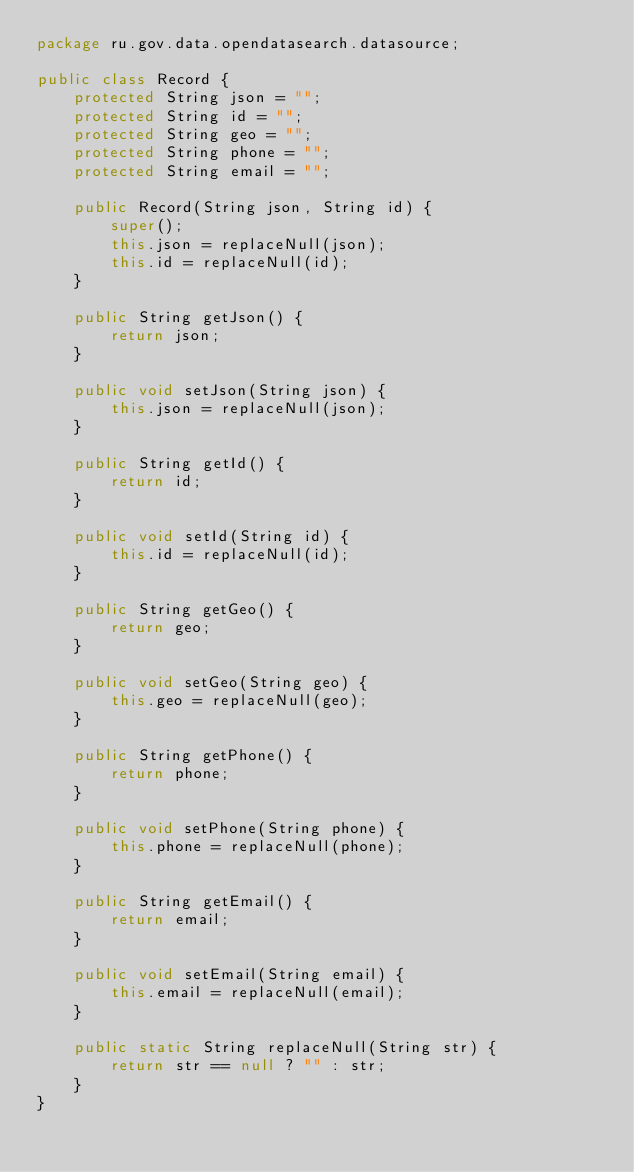Convert code to text. <code><loc_0><loc_0><loc_500><loc_500><_Java_>package ru.gov.data.opendatasearch.datasource;

public class Record {
    protected String json = "";
    protected String id = "";
    protected String geo = "";
    protected String phone = "";
    protected String email = "";

    public Record(String json, String id) {
        super();
        this.json = replaceNull(json);
        this.id = replaceNull(id);
    }

    public String getJson() {
        return json;
    }

    public void setJson(String json) {
        this.json = replaceNull(json);
    }

    public String getId() {
        return id;
    }

    public void setId(String id) {
        this.id = replaceNull(id);
    }

    public String getGeo() {
        return geo;
    }

    public void setGeo(String geo) {
        this.geo = replaceNull(geo);
    }

    public String getPhone() {
        return phone;
    }

    public void setPhone(String phone) {
        this.phone = replaceNull(phone);
    }

    public String getEmail() {
        return email;
    }

    public void setEmail(String email) {
        this.email = replaceNull(email);
    }

    public static String replaceNull(String str) {
        return str == null ? "" : str;
    }
}
</code> 